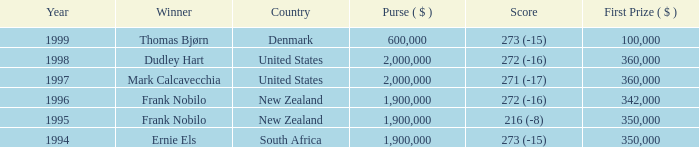In the years after frank nobilo won with a 272 (-16) score in 1996, what was the cumulative purse? None. 